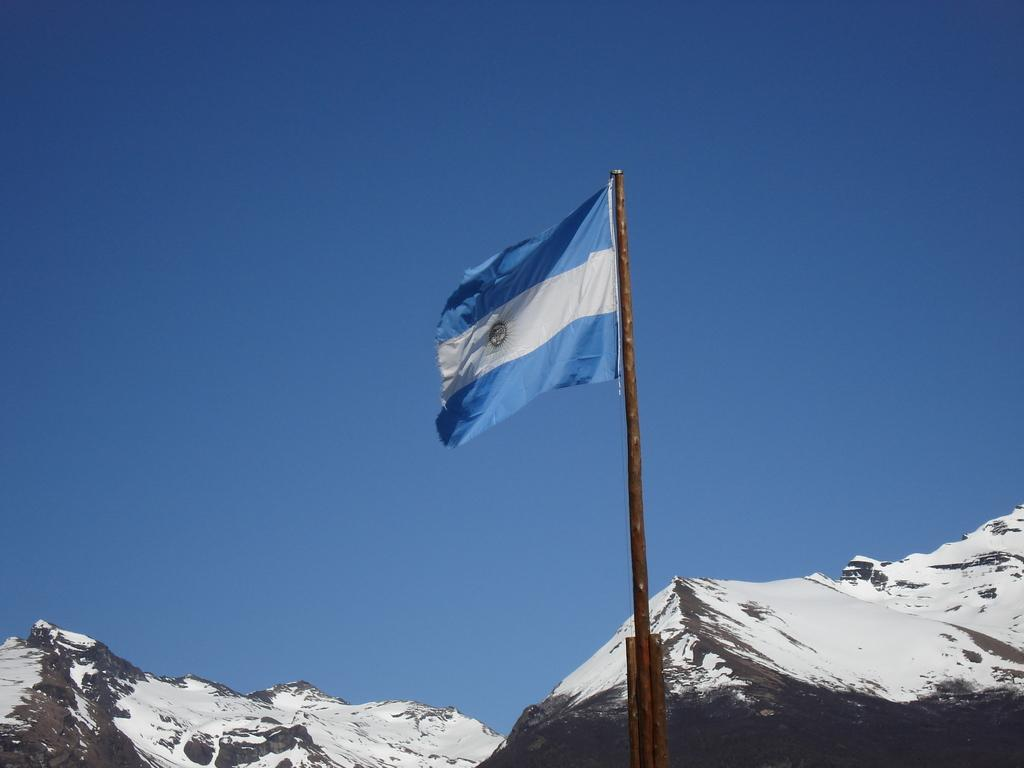What is the main object in the middle of the image? There is a flag in the middle of the image. What is the flag attached to? The flag is attached to a pole. What can be seen in the background of the image? Mountains are visible in the background of the image. What is the condition of the mountains? The mountains are covered with snow. What is the color of the sky in the image? The sky is blue in color. What type of brass instrument can be heard playing in the image? There is no brass instrument or sound present in the image; it is a visual representation of a flag, mountains, and sky. 